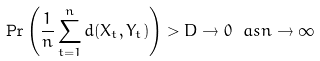<formula> <loc_0><loc_0><loc_500><loc_500>\Pr \left ( \frac { 1 } { n } \sum _ { t = 1 } ^ { n } d ( X _ { t } , Y _ { t } ) \right ) > D \to 0 \ a s n \to \infty</formula> 